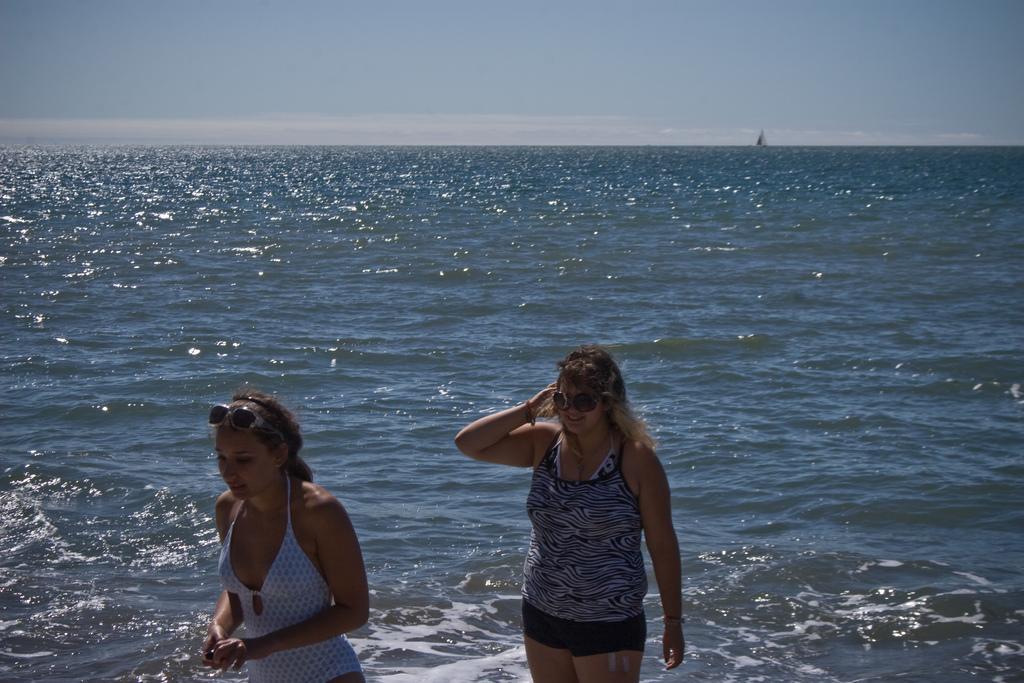How many people are in the image? There are two people in the image. What is located behind the people in the image? There is a boat in the water behind the people. What can be seen in the background of the image? The sky is visible in the background of the image. What type of authority does the grandfather have in the image? There is no grandfather present in the image, and therefore no authority can be attributed to him. 